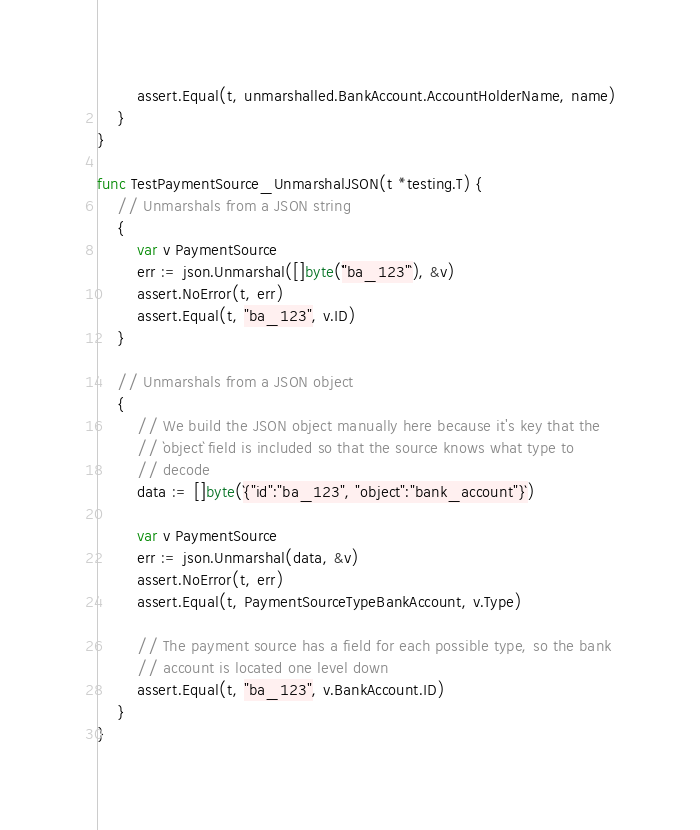<code> <loc_0><loc_0><loc_500><loc_500><_Go_>		assert.Equal(t, unmarshalled.BankAccount.AccountHolderName, name)
	}
}

func TestPaymentSource_UnmarshalJSON(t *testing.T) {
	// Unmarshals from a JSON string
	{
		var v PaymentSource
		err := json.Unmarshal([]byte(`"ba_123"`), &v)
		assert.NoError(t, err)
		assert.Equal(t, "ba_123", v.ID)
	}

	// Unmarshals from a JSON object
	{
		// We build the JSON object manually here because it's key that the
		// `object` field is included so that the source knows what type to
		// decode
		data := []byte(`{"id":"ba_123", "object":"bank_account"}`)

		var v PaymentSource
		err := json.Unmarshal(data, &v)
		assert.NoError(t, err)
		assert.Equal(t, PaymentSourceTypeBankAccount, v.Type)

		// The payment source has a field for each possible type, so the bank
		// account is located one level down
		assert.Equal(t, "ba_123", v.BankAccount.ID)
	}
}
</code> 